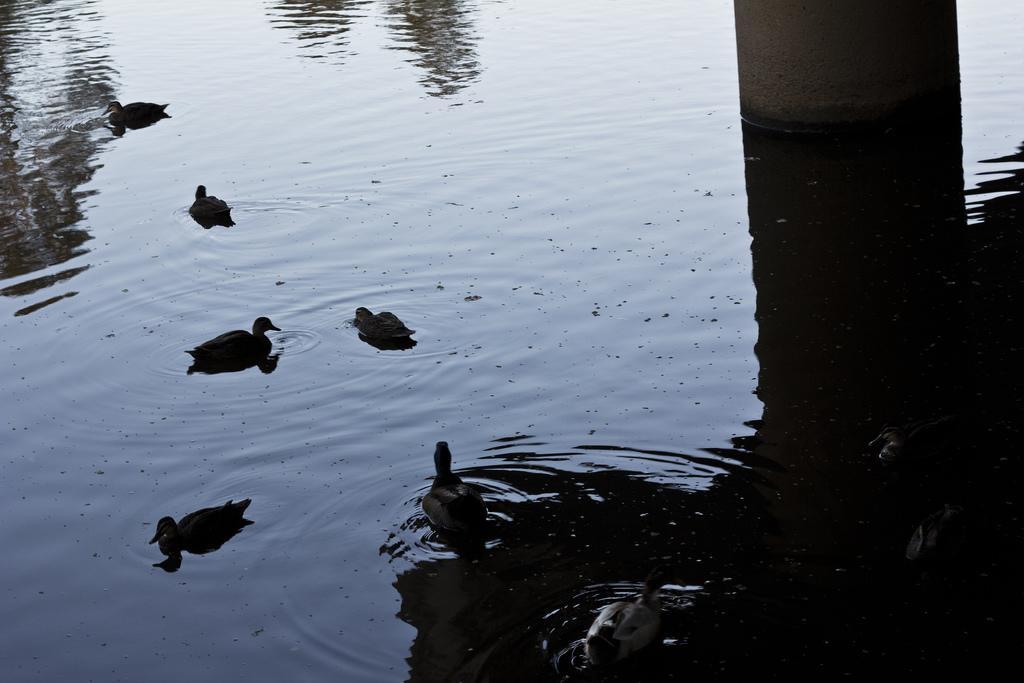How would you summarize this image in a sentence or two? As we can see in the image there is water and ducks. The image is little dark. 